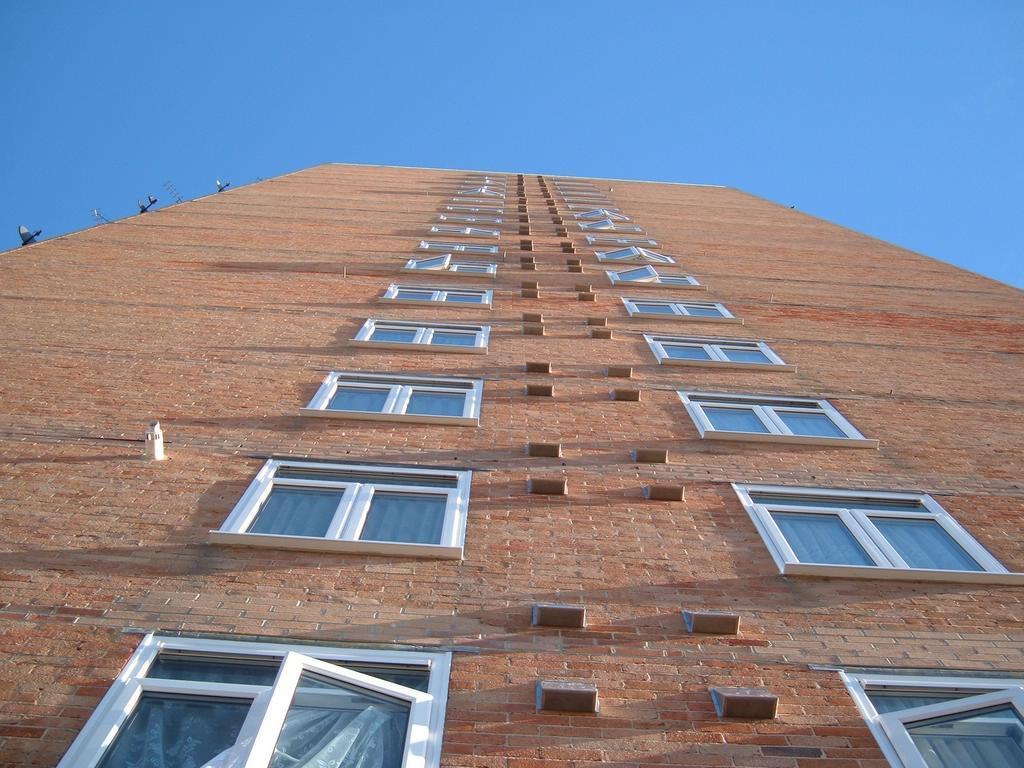In one or two sentences, can you explain what this image depicts? In this image we can see brown color brick building with glass windows. The sky is in blue color. 